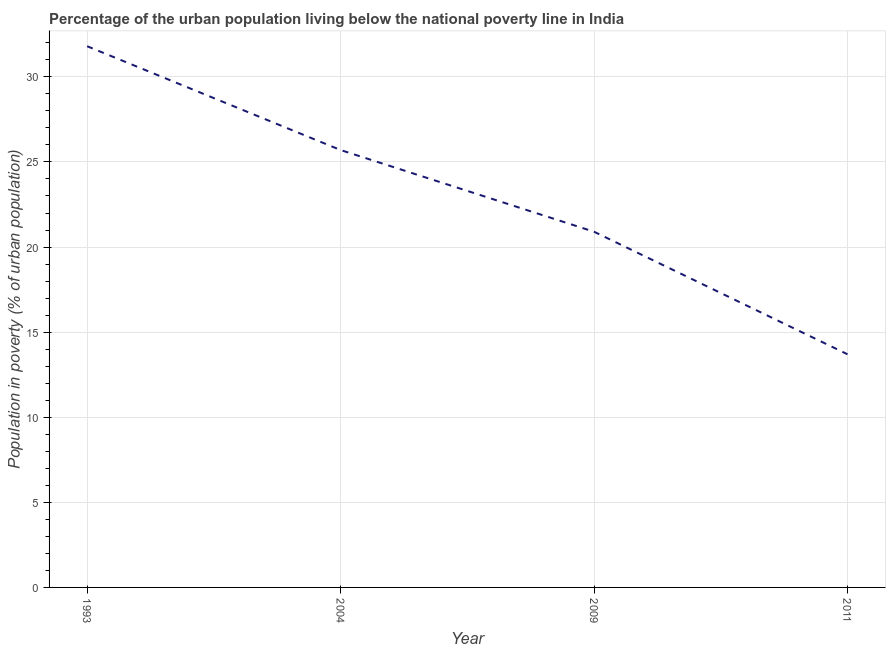Across all years, what is the maximum percentage of urban population living below poverty line?
Offer a very short reply. 31.8. Across all years, what is the minimum percentage of urban population living below poverty line?
Make the answer very short. 13.7. In which year was the percentage of urban population living below poverty line maximum?
Ensure brevity in your answer.  1993. What is the sum of the percentage of urban population living below poverty line?
Your response must be concise. 92.1. What is the average percentage of urban population living below poverty line per year?
Your response must be concise. 23.03. What is the median percentage of urban population living below poverty line?
Your response must be concise. 23.3. In how many years, is the percentage of urban population living below poverty line greater than 9 %?
Keep it short and to the point. 4. Do a majority of the years between 2011 and 1993 (inclusive) have percentage of urban population living below poverty line greater than 22 %?
Keep it short and to the point. Yes. What is the ratio of the percentage of urban population living below poverty line in 2004 to that in 2009?
Keep it short and to the point. 1.23. What is the difference between the highest and the second highest percentage of urban population living below poverty line?
Your answer should be compact. 6.1. In how many years, is the percentage of urban population living below poverty line greater than the average percentage of urban population living below poverty line taken over all years?
Provide a succinct answer. 2. How many lines are there?
Your answer should be very brief. 1. Does the graph contain any zero values?
Ensure brevity in your answer.  No. Does the graph contain grids?
Your answer should be very brief. Yes. What is the title of the graph?
Offer a very short reply. Percentage of the urban population living below the national poverty line in India. What is the label or title of the Y-axis?
Make the answer very short. Population in poverty (% of urban population). What is the Population in poverty (% of urban population) in 1993?
Make the answer very short. 31.8. What is the Population in poverty (% of urban population) of 2004?
Provide a short and direct response. 25.7. What is the Population in poverty (% of urban population) in 2009?
Your answer should be compact. 20.9. What is the difference between the Population in poverty (% of urban population) in 1993 and 2009?
Your answer should be very brief. 10.9. What is the difference between the Population in poverty (% of urban population) in 1993 and 2011?
Make the answer very short. 18.1. What is the difference between the Population in poverty (% of urban population) in 2004 and 2009?
Your answer should be compact. 4.8. What is the difference between the Population in poverty (% of urban population) in 2004 and 2011?
Your answer should be compact. 12. What is the ratio of the Population in poverty (% of urban population) in 1993 to that in 2004?
Your answer should be very brief. 1.24. What is the ratio of the Population in poverty (% of urban population) in 1993 to that in 2009?
Keep it short and to the point. 1.52. What is the ratio of the Population in poverty (% of urban population) in 1993 to that in 2011?
Your answer should be very brief. 2.32. What is the ratio of the Population in poverty (% of urban population) in 2004 to that in 2009?
Keep it short and to the point. 1.23. What is the ratio of the Population in poverty (% of urban population) in 2004 to that in 2011?
Keep it short and to the point. 1.88. What is the ratio of the Population in poverty (% of urban population) in 2009 to that in 2011?
Provide a succinct answer. 1.53. 